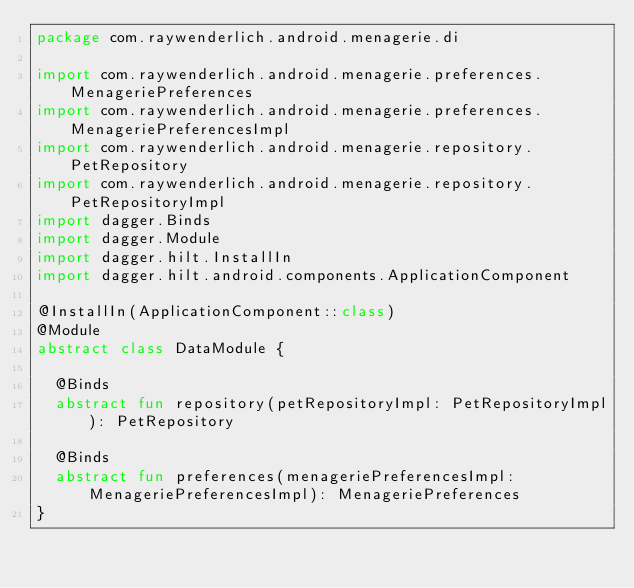Convert code to text. <code><loc_0><loc_0><loc_500><loc_500><_Kotlin_>package com.raywenderlich.android.menagerie.di

import com.raywenderlich.android.menagerie.preferences.MenageriePreferences
import com.raywenderlich.android.menagerie.preferences.MenageriePreferencesImpl
import com.raywenderlich.android.menagerie.repository.PetRepository
import com.raywenderlich.android.menagerie.repository.PetRepositoryImpl
import dagger.Binds
import dagger.Module
import dagger.hilt.InstallIn
import dagger.hilt.android.components.ApplicationComponent

@InstallIn(ApplicationComponent::class)
@Module
abstract class DataModule {

  @Binds
  abstract fun repository(petRepositoryImpl: PetRepositoryImpl): PetRepository

  @Binds
  abstract fun preferences(menageriePreferencesImpl: MenageriePreferencesImpl): MenageriePreferences
}</code> 